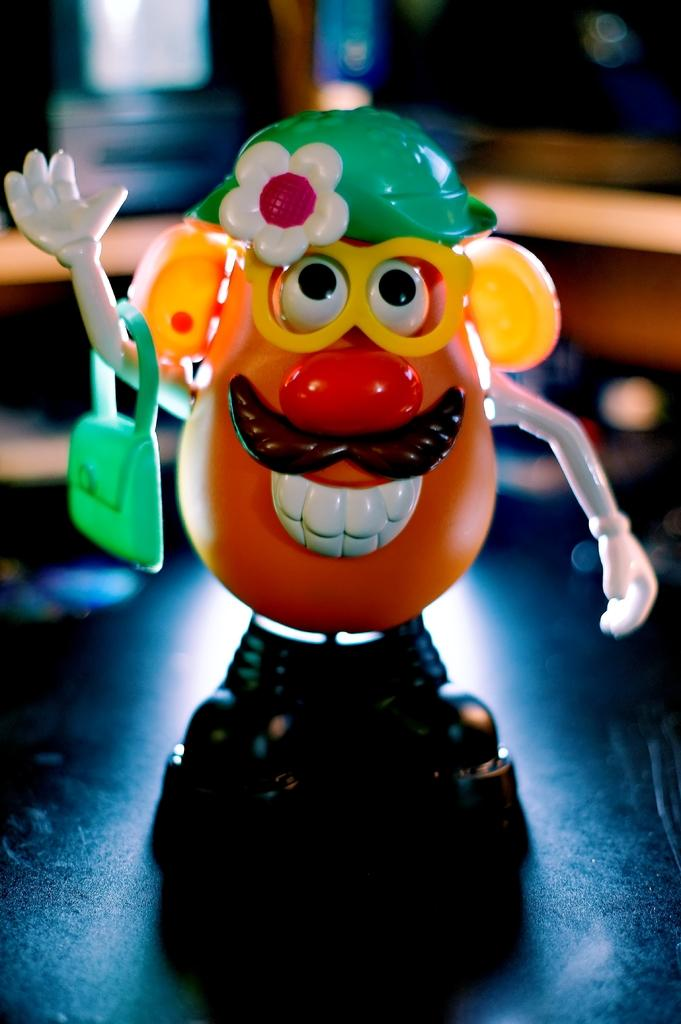What is the main subject in the middle of the image? There is a small toy in the middle of the image. What is the toy holding in its hand? The toy is holding a handbag. What accessory is the toy wearing? The toy is wearing spectacles. Can you describe the background of the image? The background of the image is blurry. What type of doctor is attending to the toy in the image? There is no doctor present in the image; it only features a small toy holding a handbag and wearing spectacles. 